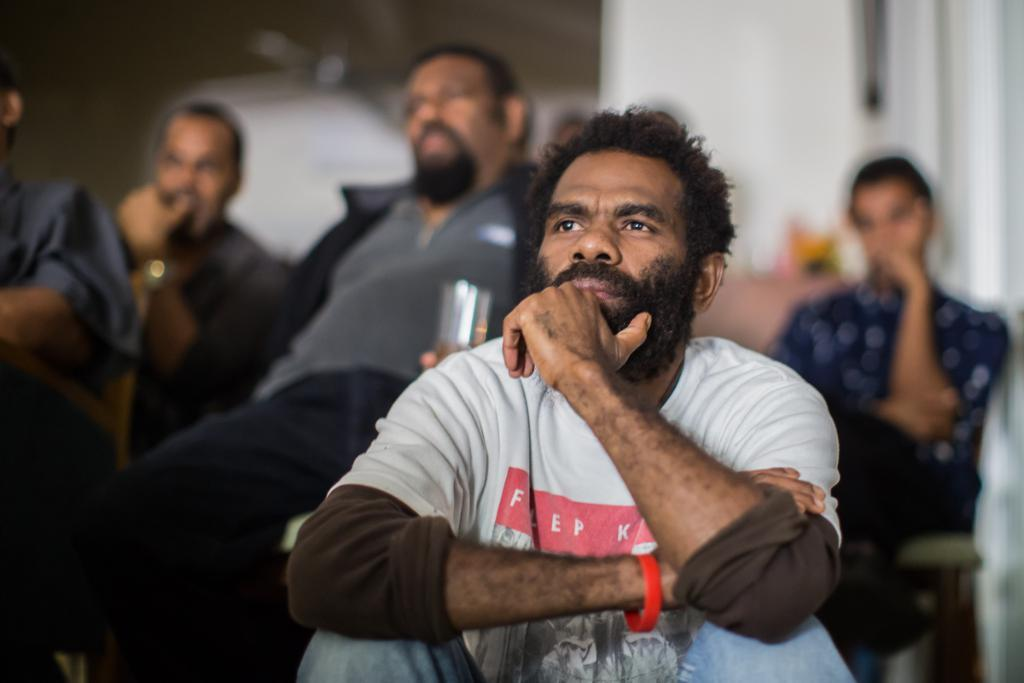Who or what can be seen in the image? There are people in the image. What are the people doing in the image? The people are sitting on chairs. Can you describe the background of the image? The background of the image is blurred. What type of disease is affecting the giants in the image? There are no giants present in the image, and therefore no disease can be observed. What is the title of the image? The provided facts do not mention a title for the image. 